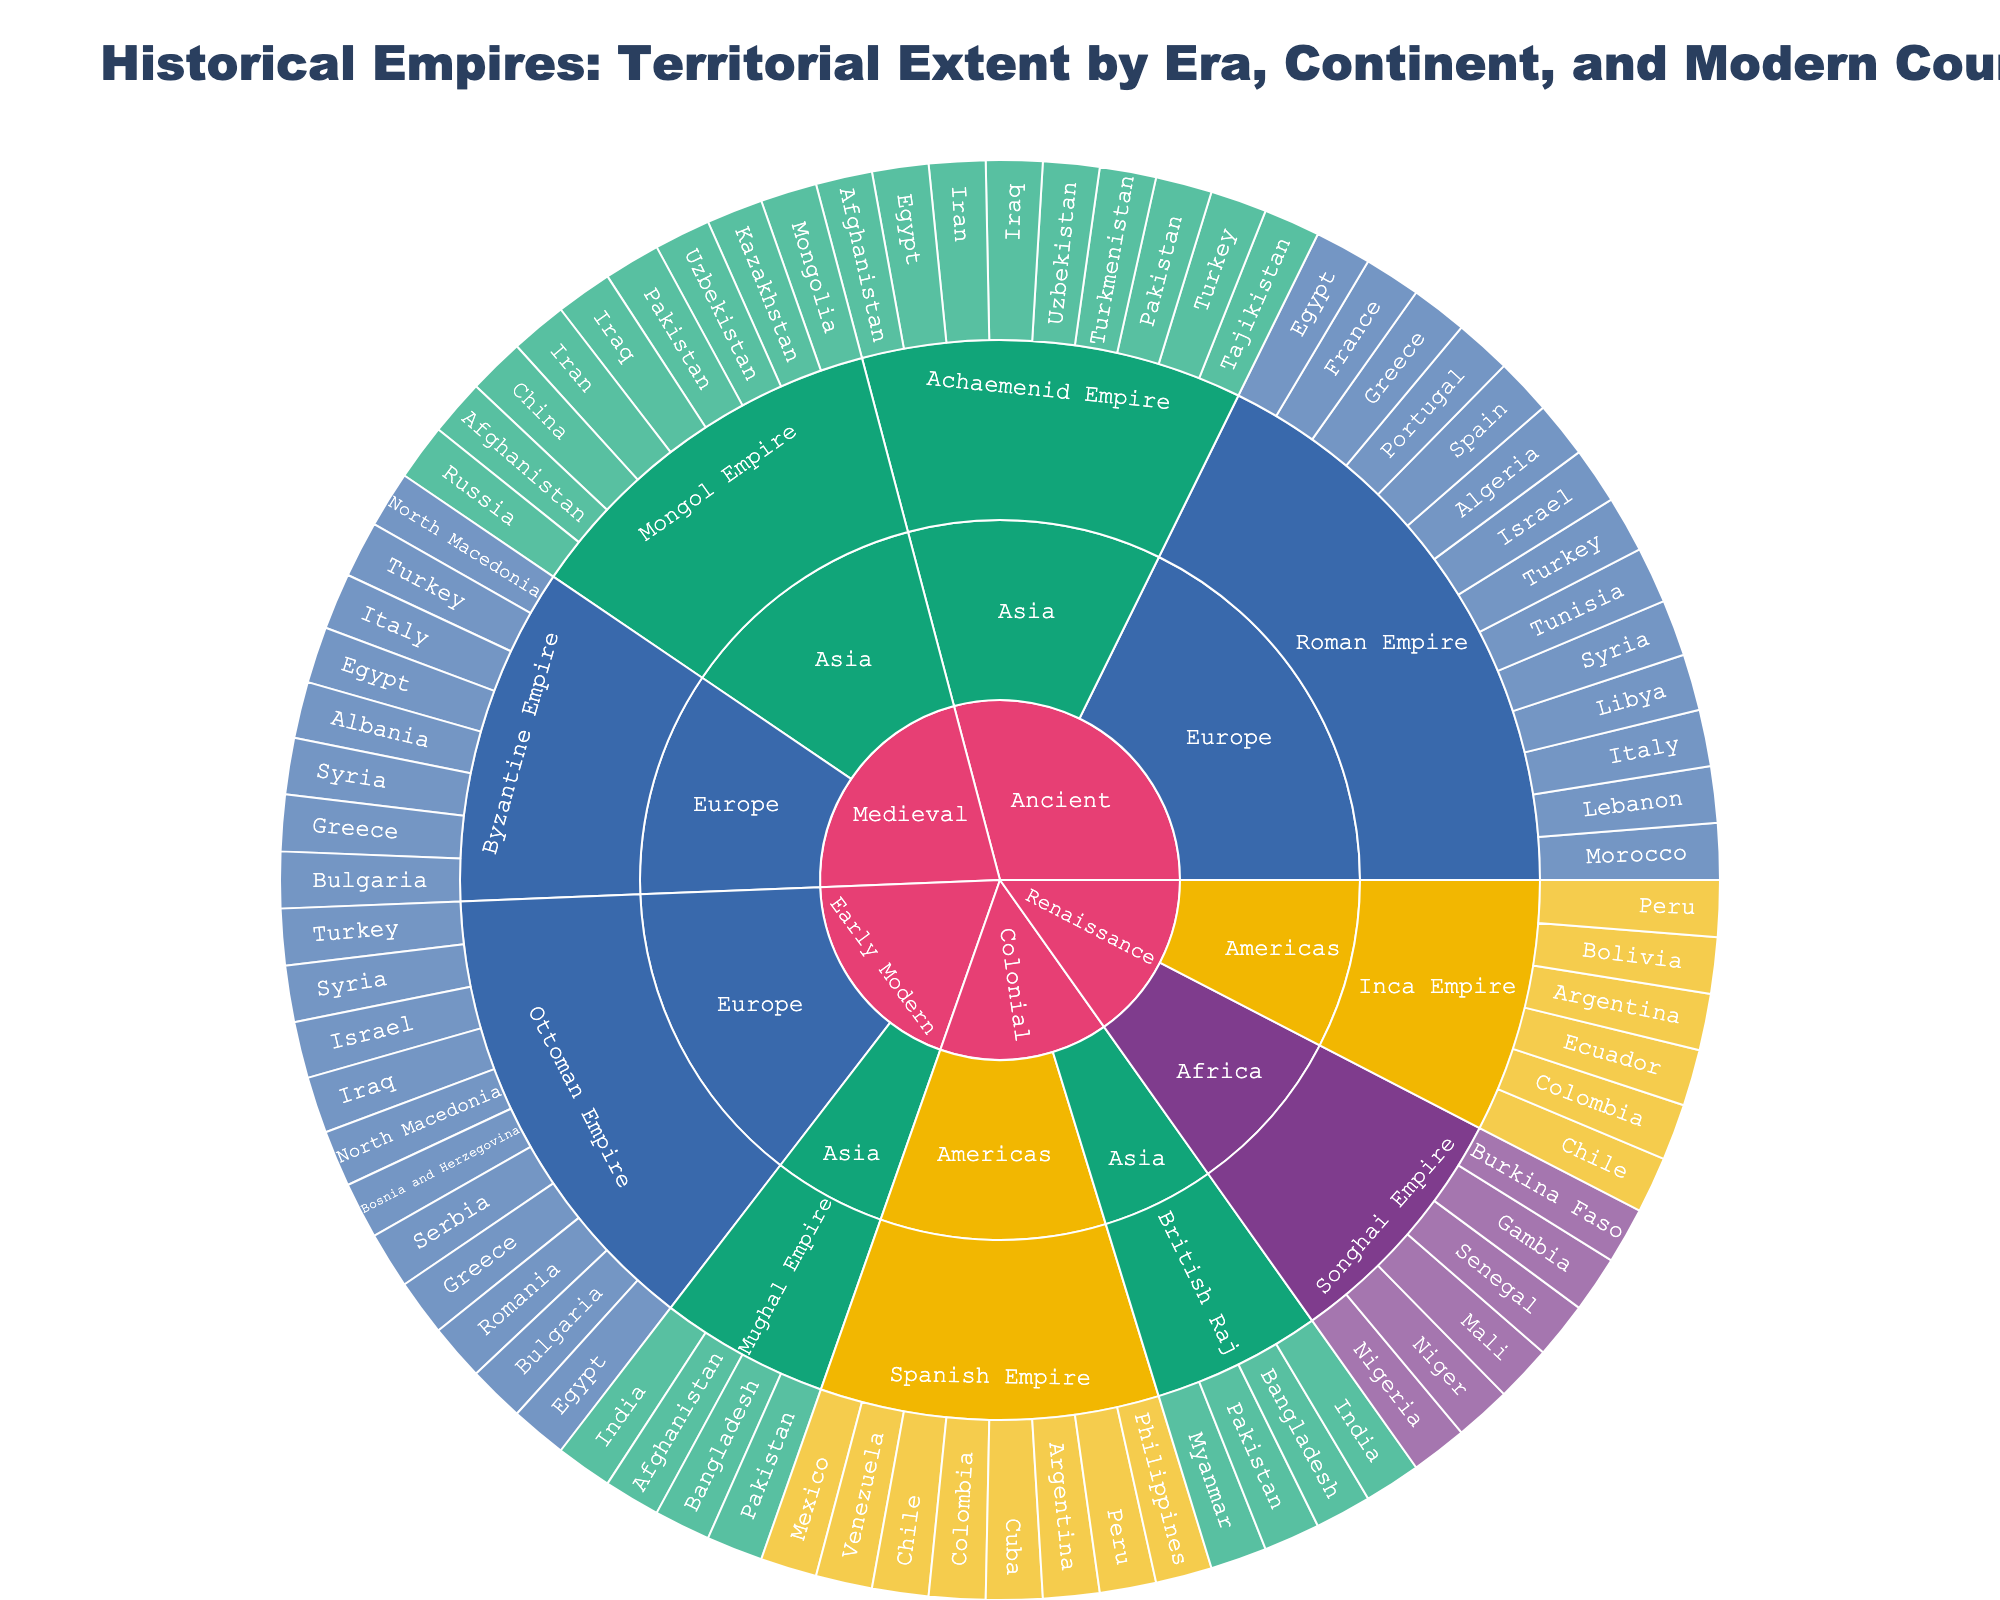What's the title of the figure? The title is usually found at the top of the figure and it provides a general idea about what the figure represents.
Answer: Historical Empires: Territorial Extent by Era, Continent, and Modern Countries How many main Eras are represented in the figure? The main Eras are at the first level of the hierarchy in the sunburst plot. Count the unique segments at this level.
Answer: 5 Which continent has the most empires represented in the Medieval Era? Locate the Medieval Era in the figure, then observe which continent has the most segments branching from it. Count the empires for each continent and compare.
Answer: Asia Which modern country appears under both the Roman Empire and the Byzantine Empire? Under the Ancient Era, find the Roman Empire and list its modern countries. Then switch to the Medieval Era, locate the Byzantine Empire, and list its modern countries. Look for overlaps.
Answer: Turkey How many modern countries were part of the Achaemenid Empire? Go to the Ancient Era, find the Achaemenid Empire, and count the number of modern countries branching from it.
Answer: 9 Which empire in the Renaissance Era spans across the largest number of current countries? Check the Renaissance Era, and compare the number of modern countries listed under each empire.
Answer: Inca Empire Compare the number of modern countries covered by the Ottoman Empire and the Mughal Empire. Which one encompasses more countries? Go to the Early Modern Era, locate both the Ottoman and Mughal Empires, and count the modern countries for each.
Answer: Ottoman Empire Which era has the highest number of empires? Count the number of unique empires listed under each era and compare.
Answer: Colonial Identify a modern country that was part of both the Spanish Empire and the Inca Empire. Find the Spanish Empire under Colonial Era and the Inca Empire under Renaissance Era, and list their modern countries. Look for common countries.
Answer: Peru How many empires in the figure include Egypt in their territories? Search for Egypt in the figure and count how many different empires it appears under.
Answer: 4 